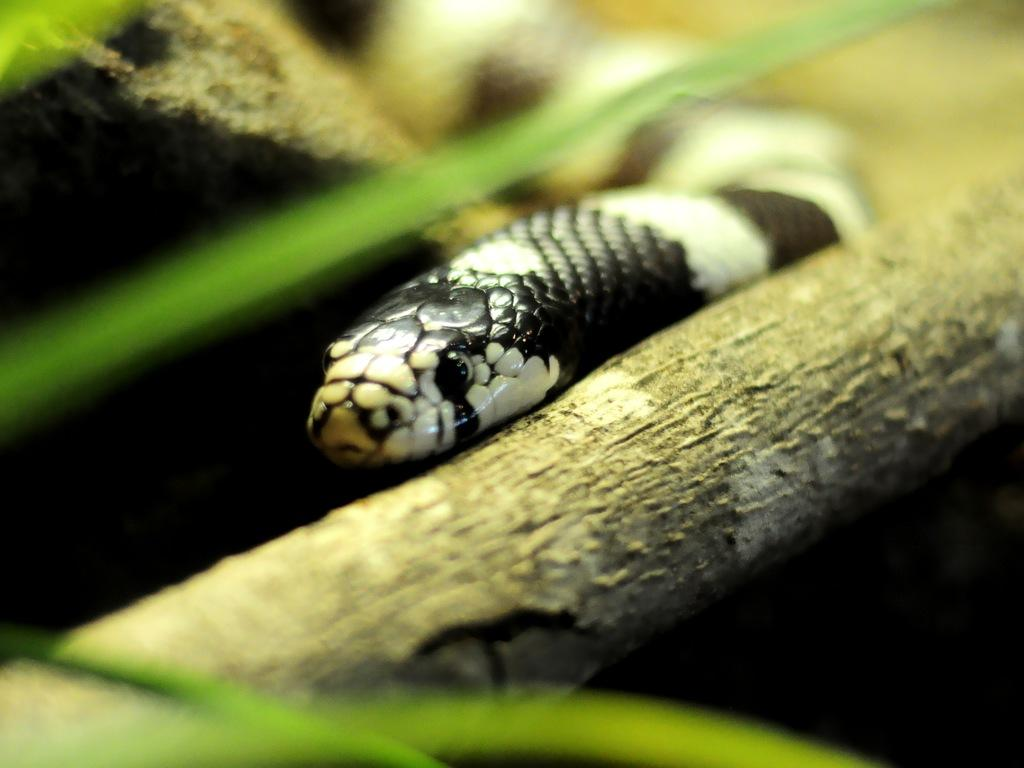What is the main subject in the center of the image? There is a snake in the center of the image. What can be seen in the background of the image? There is a branch and leaves present in the background of the image. How many trips to the beach are shown in the image? There are no trips to the beach depicted in the image; it features a snake and background elements. What type of cobweb can be seen in the image? There is no cobweb present in the image. 